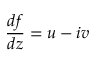<formula> <loc_0><loc_0><loc_500><loc_500>{ \frac { d f } { d z } } = u - i v</formula> 